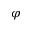<formula> <loc_0><loc_0><loc_500><loc_500>\varphi</formula> 